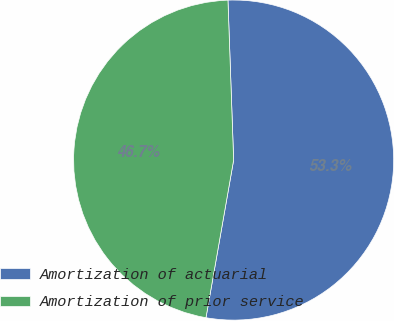Convert chart to OTSL. <chart><loc_0><loc_0><loc_500><loc_500><pie_chart><fcel>Amortization of actuarial<fcel>Amortization of prior service<nl><fcel>53.33%<fcel>46.67%<nl></chart> 